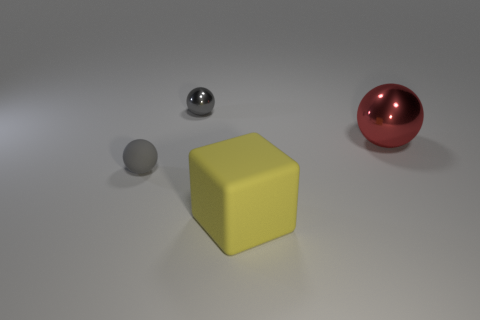Are there fewer red metal balls that are on the right side of the red metal object than small gray spheres?
Keep it short and to the point. Yes. The small gray thing that is the same material as the yellow block is what shape?
Make the answer very short. Sphere. What number of shiny objects are either big yellow things or small balls?
Ensure brevity in your answer.  1. Are there the same number of rubber objects that are behind the red thing and big objects?
Provide a succinct answer. No. Is the color of the metal ball left of the big cube the same as the large sphere?
Ensure brevity in your answer.  No. There is a thing that is both behind the gray rubber object and to the left of the red ball; what is its material?
Your response must be concise. Metal. There is a rubber thing on the left side of the large rubber thing; is there a big yellow block on the left side of it?
Ensure brevity in your answer.  No. Is the material of the block the same as the large red object?
Provide a short and direct response. No. What shape is the object that is in front of the large sphere and behind the big yellow cube?
Ensure brevity in your answer.  Sphere. How big is the gray object to the left of the tiny gray ball right of the tiny matte ball?
Offer a very short reply. Small. 